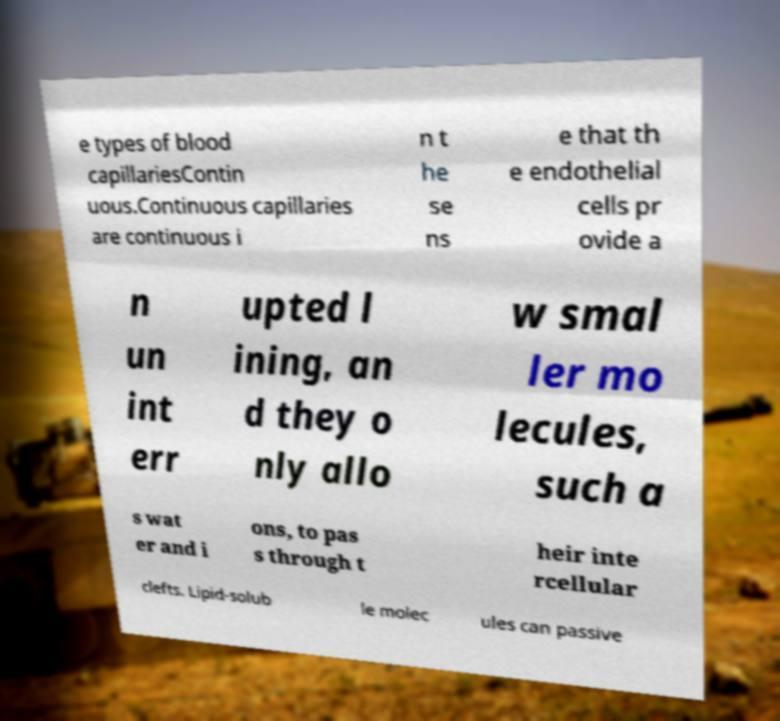Could you assist in decoding the text presented in this image and type it out clearly? e types of blood capillariesContin uous.Continuous capillaries are continuous i n t he se ns e that th e endothelial cells pr ovide a n un int err upted l ining, an d they o nly allo w smal ler mo lecules, such a s wat er and i ons, to pas s through t heir inte rcellular clefts. Lipid-solub le molec ules can passive 